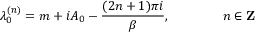<formula> <loc_0><loc_0><loc_500><loc_500>\lambda _ { 0 } ^ { ( n ) } = m + i A _ { 0 } - \frac { ( 2 n + 1 ) \pi i } { \beta } , \quad n \in { Z }</formula> 